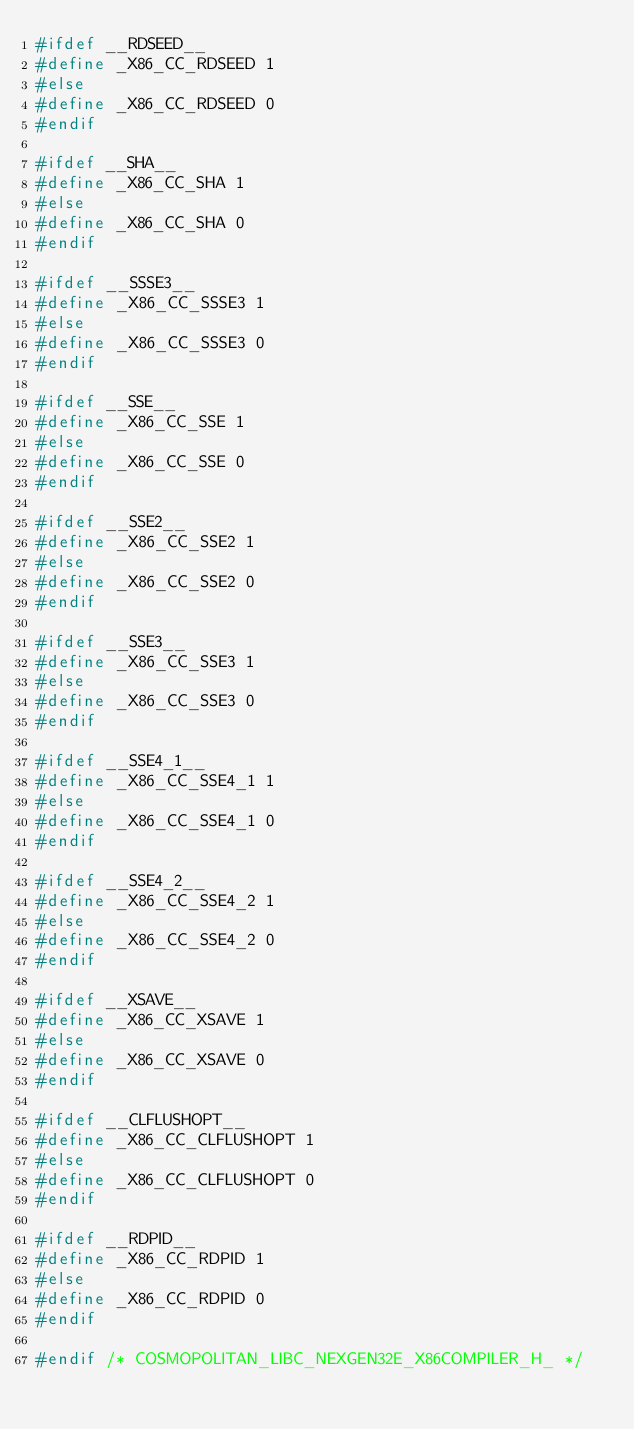<code> <loc_0><loc_0><loc_500><loc_500><_C_>#ifdef __RDSEED__
#define _X86_CC_RDSEED 1
#else
#define _X86_CC_RDSEED 0
#endif

#ifdef __SHA__
#define _X86_CC_SHA 1
#else
#define _X86_CC_SHA 0
#endif

#ifdef __SSSE3__
#define _X86_CC_SSSE3 1
#else
#define _X86_CC_SSSE3 0
#endif

#ifdef __SSE__
#define _X86_CC_SSE 1
#else
#define _X86_CC_SSE 0
#endif

#ifdef __SSE2__
#define _X86_CC_SSE2 1
#else
#define _X86_CC_SSE2 0
#endif

#ifdef __SSE3__
#define _X86_CC_SSE3 1
#else
#define _X86_CC_SSE3 0
#endif

#ifdef __SSE4_1__
#define _X86_CC_SSE4_1 1
#else
#define _X86_CC_SSE4_1 0
#endif

#ifdef __SSE4_2__
#define _X86_CC_SSE4_2 1
#else
#define _X86_CC_SSE4_2 0
#endif

#ifdef __XSAVE__
#define _X86_CC_XSAVE 1
#else
#define _X86_CC_XSAVE 0
#endif

#ifdef __CLFLUSHOPT__
#define _X86_CC_CLFLUSHOPT 1
#else
#define _X86_CC_CLFLUSHOPT 0
#endif

#ifdef __RDPID__
#define _X86_CC_RDPID 1
#else
#define _X86_CC_RDPID 0
#endif

#endif /* COSMOPOLITAN_LIBC_NEXGEN32E_X86COMPILER_H_ */
</code> 